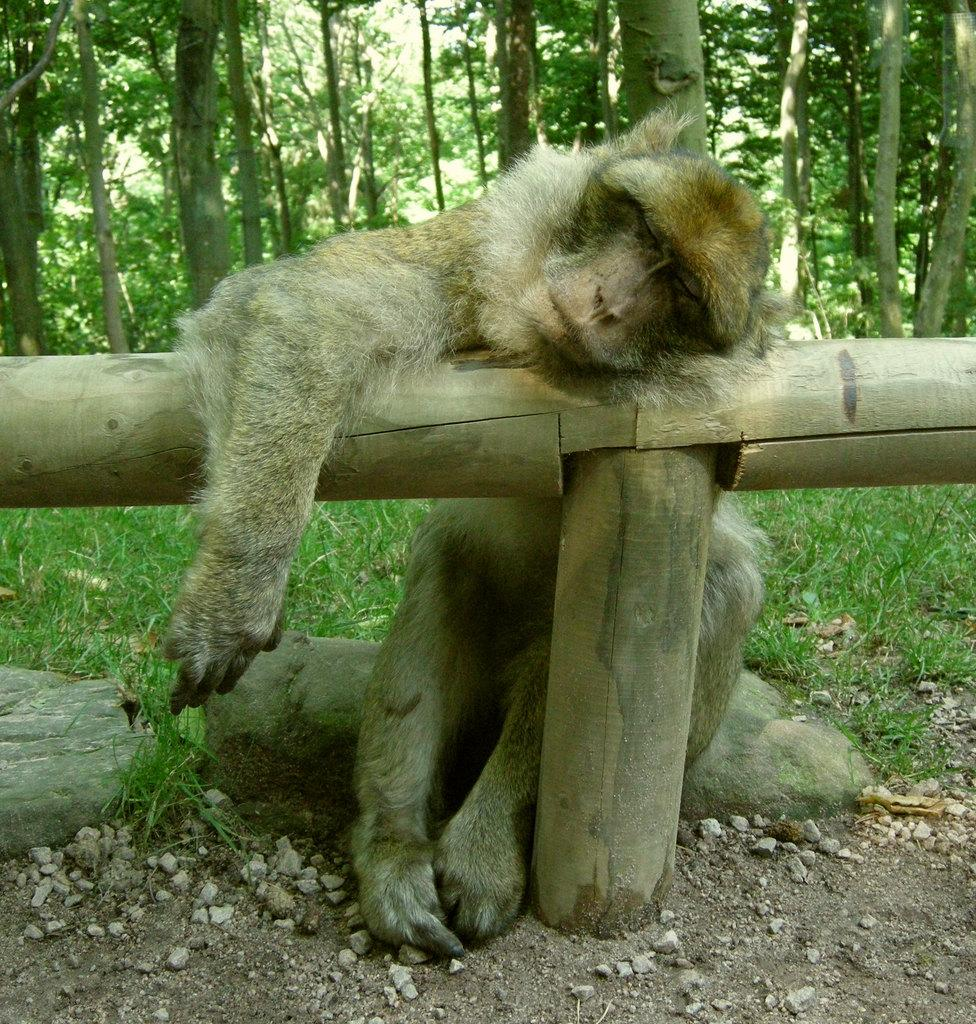What animal is present in the image? There is a monkey in the image. What is the monkey doing in the image? The monkey is sitting on a rock and resting her head on a wooden pole. What can be seen in the background of the image? There are trees visible in the background of the image. What type of meal is the monkey eating in the image? There is no meal present in the image; the monkey is resting her head on a wooden pole. Is the monkey in the image working on a manuscript as a writer? There is no indication in the image that the monkey is a writer or working on a manuscript. 